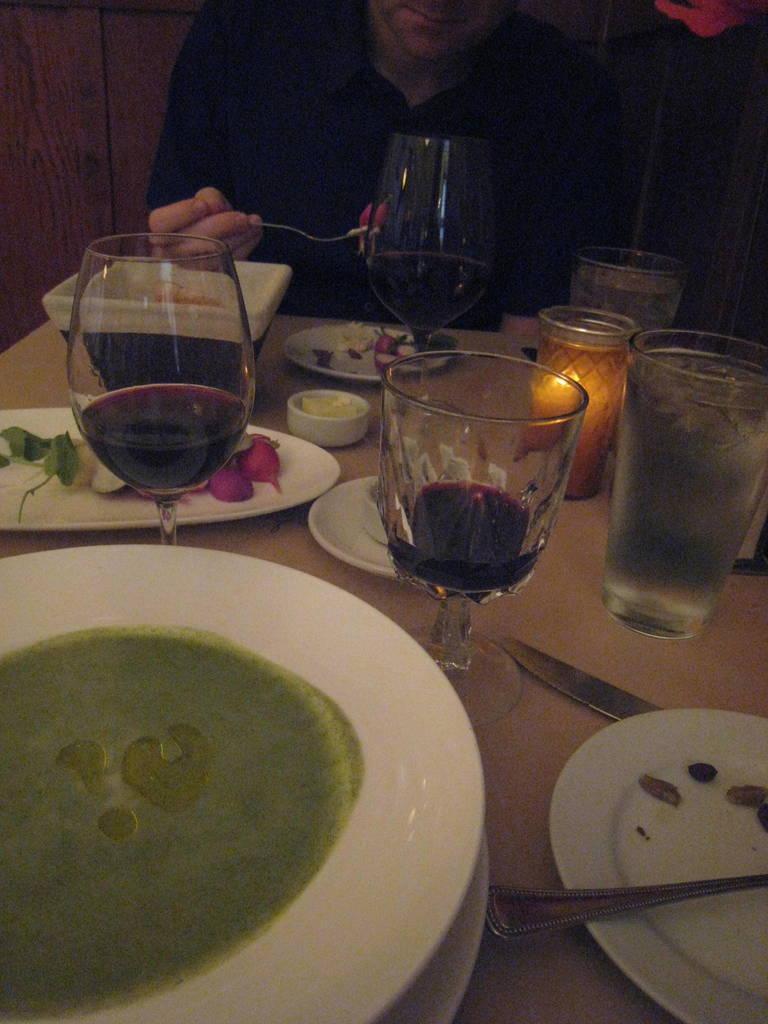Please provide a concise description of this image. A man is having food at a table with some glasses and plates on it. 